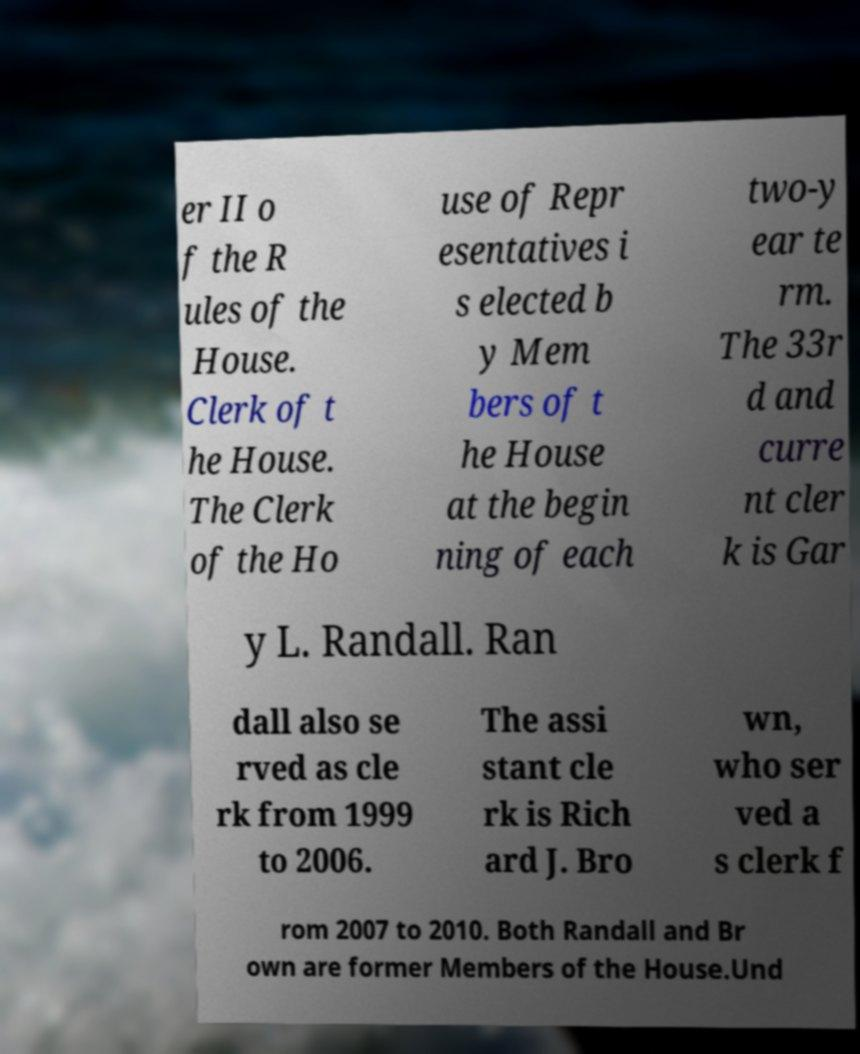Could you assist in decoding the text presented in this image and type it out clearly? er II o f the R ules of the House. Clerk of t he House. The Clerk of the Ho use of Repr esentatives i s elected b y Mem bers of t he House at the begin ning of each two-y ear te rm. The 33r d and curre nt cler k is Gar y L. Randall. Ran dall also se rved as cle rk from 1999 to 2006. The assi stant cle rk is Rich ard J. Bro wn, who ser ved a s clerk f rom 2007 to 2010. Both Randall and Br own are former Members of the House.Und 